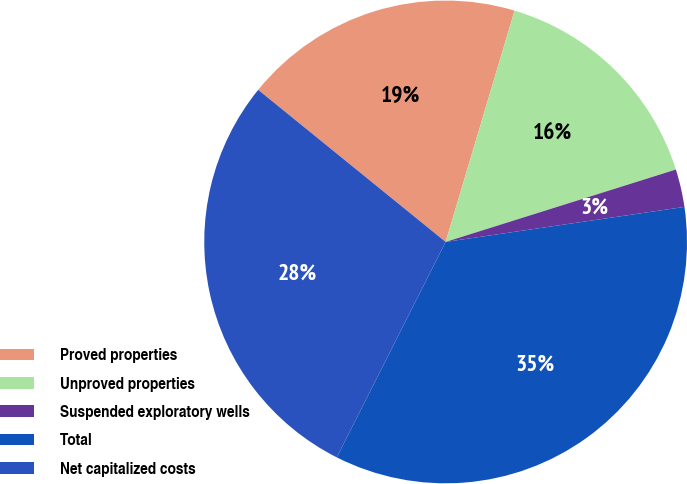<chart> <loc_0><loc_0><loc_500><loc_500><pie_chart><fcel>Proved properties<fcel>Unproved properties<fcel>Suspended exploratory wells<fcel>Total<fcel>Net capitalized costs<nl><fcel>18.76%<fcel>15.54%<fcel>2.53%<fcel>34.76%<fcel>28.4%<nl></chart> 